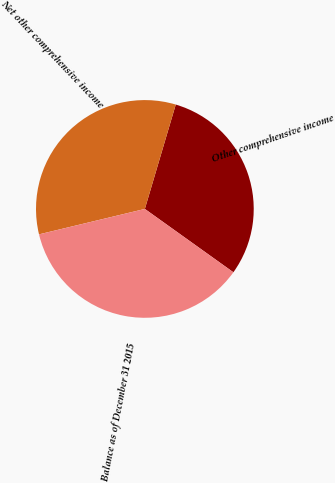Convert chart to OTSL. <chart><loc_0><loc_0><loc_500><loc_500><pie_chart><fcel>Other comprehensive income<fcel>Net other comprehensive income<fcel>Balance as of December 31 2015<nl><fcel>30.3%<fcel>33.33%<fcel>36.36%<nl></chart> 